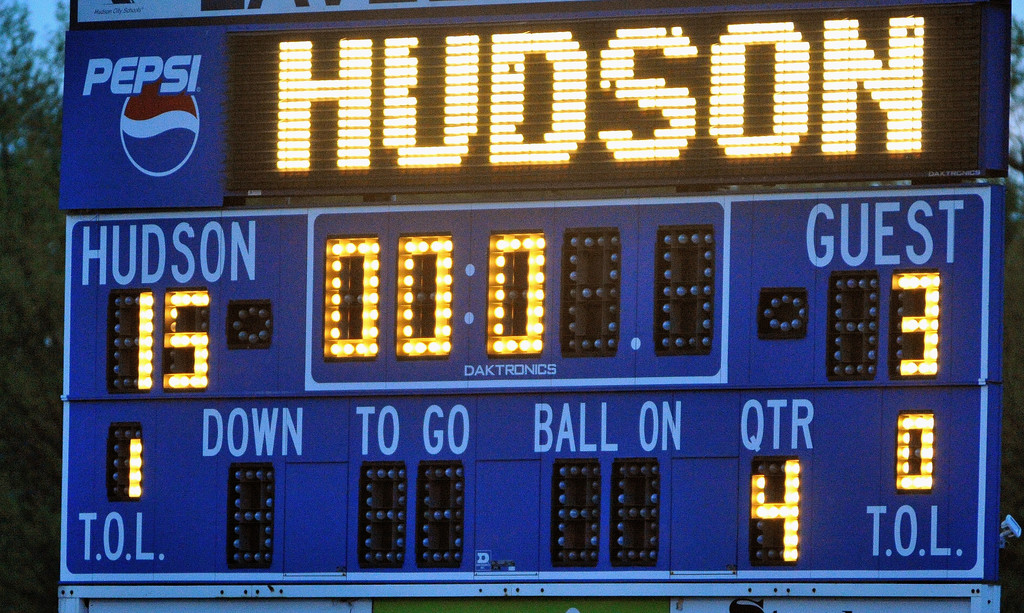What does the presence of a Pepsi logo on the scoreboard imply about the event? The Pepsi logo on the scoreboard suggests that Pepsi is a sponsor of the event or the venue. This indicates commercial support and may imply that the game is of significant local or even regional importance, attracting corporate partnerships. Sponsorship by well-known brands like Pepsi often associates with higher visibility and substantial audience interest, which might also suggest the presence of media coverage or promotional activities tied to the game. How does corporate sponsorship affect the perception of sports events? Corporate sponsorship can dramatically enhance the perception of sports events. It often leads to improved facilities and more significant media attention, which increases a team's visibility and fans' engagement. Additionally, funding from sponsors like Pepsi can support enhanced event organization, better player facilities, or more extensive community outreach programs, boosting the event's prestige and the quality of the experience for participants and spectators alike. 